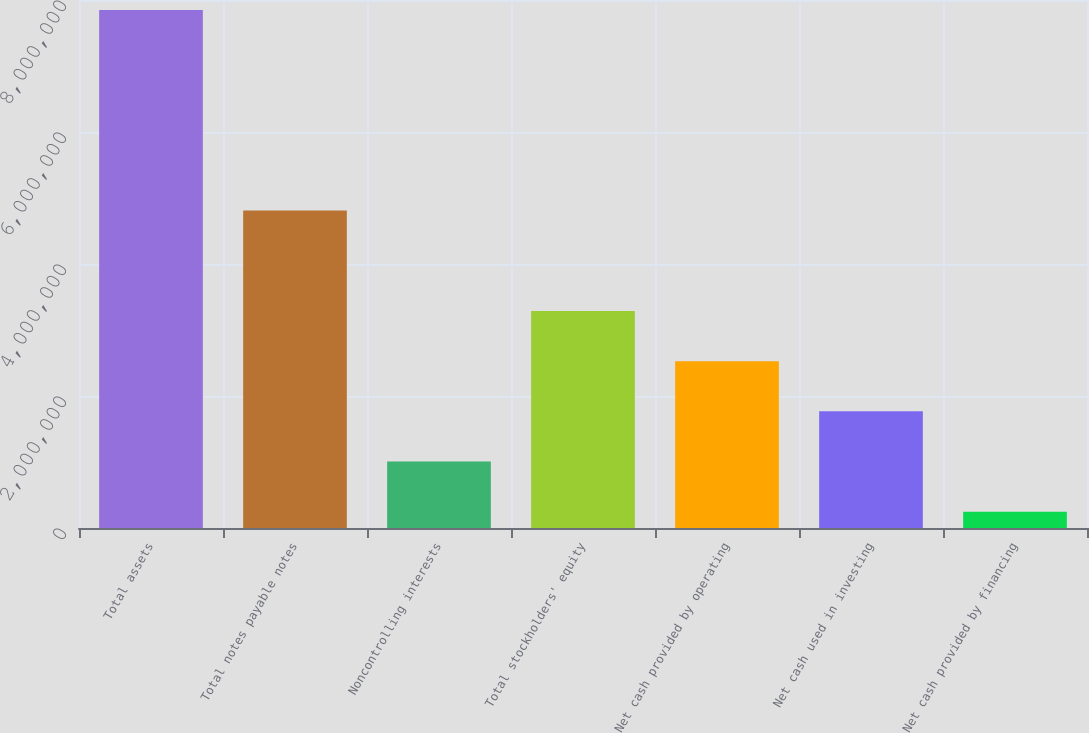<chart> <loc_0><loc_0><loc_500><loc_500><bar_chart><fcel>Total assets<fcel>Total notes payable notes<fcel>Noncontrolling interests<fcel>Total stockholders' equity<fcel>Net cash provided by operating<fcel>Net cash used in investing<fcel>Net cash provided by financing<nl><fcel>7.84798e+06<fcel>4.81152e+06<fcel>1.00732e+06<fcel>3.28754e+06<fcel>2.52747e+06<fcel>1.7674e+06<fcel>247251<nl></chart> 